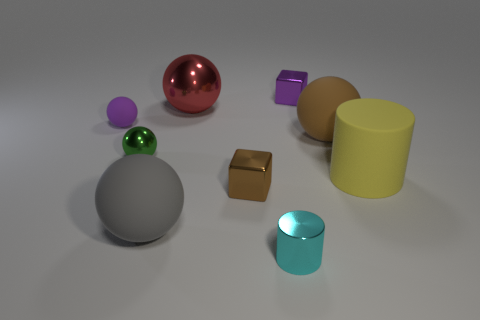Subtract all red balls. How many balls are left? 4 Subtract all big gray matte spheres. How many spheres are left? 4 Subtract all yellow spheres. Subtract all green cylinders. How many spheres are left? 5 Add 1 cyan metallic things. How many objects exist? 10 Subtract all spheres. How many objects are left? 4 Subtract 1 brown spheres. How many objects are left? 8 Subtract all brown spheres. Subtract all small brown things. How many objects are left? 7 Add 8 gray matte balls. How many gray matte balls are left? 9 Add 4 big cyan cubes. How many big cyan cubes exist? 4 